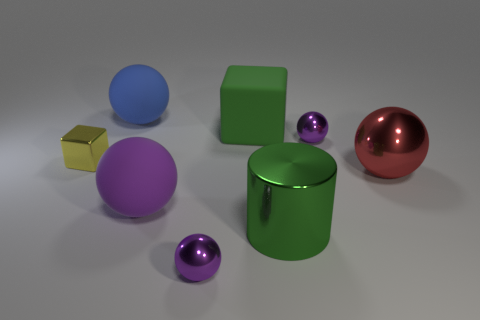Subtract all purple cylinders. How many purple balls are left? 3 Subtract all red shiny balls. How many balls are left? 4 Subtract all blue balls. How many balls are left? 4 Subtract all brown spheres. Subtract all yellow cylinders. How many spheres are left? 5 Add 2 tiny blue metal cylinders. How many objects exist? 10 Subtract all cylinders. How many objects are left? 7 Subtract 0 cyan spheres. How many objects are left? 8 Subtract all red metal things. Subtract all purple shiny objects. How many objects are left? 5 Add 5 yellow shiny objects. How many yellow shiny objects are left? 6 Add 4 large green metallic cylinders. How many large green metallic cylinders exist? 5 